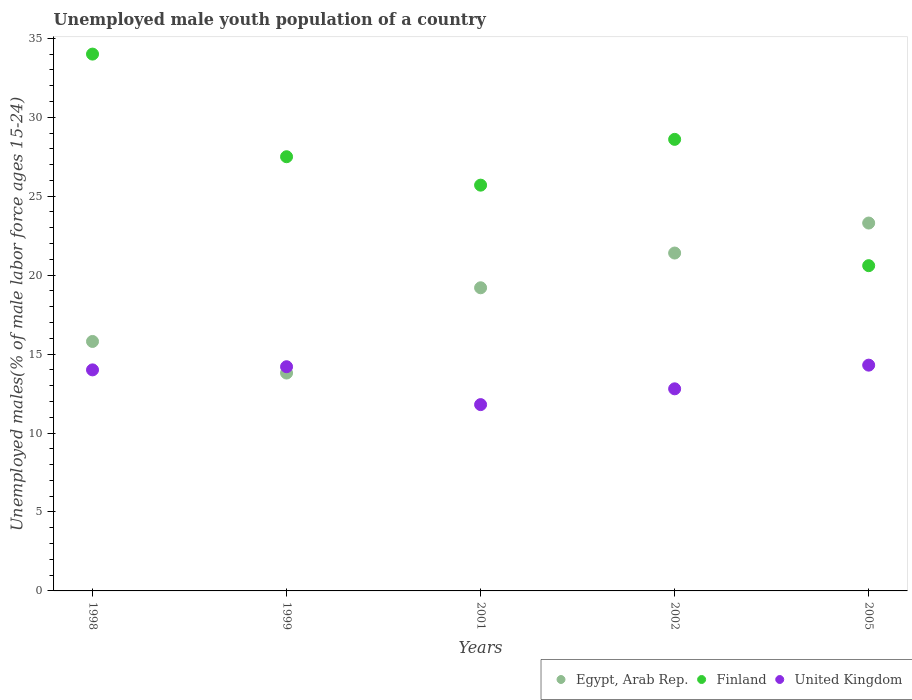How many different coloured dotlines are there?
Offer a terse response. 3. What is the percentage of unemployed male youth population in Egypt, Arab Rep. in 2001?
Keep it short and to the point. 19.2. Across all years, what is the maximum percentage of unemployed male youth population in Egypt, Arab Rep.?
Offer a terse response. 23.3. Across all years, what is the minimum percentage of unemployed male youth population in United Kingdom?
Offer a terse response. 11.8. In which year was the percentage of unemployed male youth population in Egypt, Arab Rep. maximum?
Provide a short and direct response. 2005. What is the total percentage of unemployed male youth population in Finland in the graph?
Give a very brief answer. 136.4. What is the difference between the percentage of unemployed male youth population in United Kingdom in 1998 and that in 2001?
Your answer should be compact. 2.2. What is the difference between the percentage of unemployed male youth population in Egypt, Arab Rep. in 2005 and the percentage of unemployed male youth population in Finland in 2001?
Provide a succinct answer. -2.4. What is the average percentage of unemployed male youth population in Egypt, Arab Rep. per year?
Your response must be concise. 18.7. In the year 2001, what is the difference between the percentage of unemployed male youth population in Finland and percentage of unemployed male youth population in United Kingdom?
Your answer should be compact. 13.9. What is the ratio of the percentage of unemployed male youth population in Finland in 1999 to that in 2001?
Keep it short and to the point. 1.07. Is the percentage of unemployed male youth population in United Kingdom in 1998 less than that in 1999?
Offer a terse response. Yes. What is the difference between the highest and the second highest percentage of unemployed male youth population in Egypt, Arab Rep.?
Provide a succinct answer. 1.9. What is the difference between the highest and the lowest percentage of unemployed male youth population in United Kingdom?
Offer a very short reply. 2.5. Is the sum of the percentage of unemployed male youth population in Egypt, Arab Rep. in 1999 and 2001 greater than the maximum percentage of unemployed male youth population in United Kingdom across all years?
Give a very brief answer. Yes. Does the percentage of unemployed male youth population in Finland monotonically increase over the years?
Provide a succinct answer. No. Is the percentage of unemployed male youth population in Egypt, Arab Rep. strictly less than the percentage of unemployed male youth population in United Kingdom over the years?
Your answer should be very brief. No. How many dotlines are there?
Make the answer very short. 3. What is the difference between two consecutive major ticks on the Y-axis?
Your response must be concise. 5. Where does the legend appear in the graph?
Your answer should be compact. Bottom right. How are the legend labels stacked?
Provide a short and direct response. Horizontal. What is the title of the graph?
Offer a very short reply. Unemployed male youth population of a country. Does "Singapore" appear as one of the legend labels in the graph?
Make the answer very short. No. What is the label or title of the X-axis?
Give a very brief answer. Years. What is the label or title of the Y-axis?
Ensure brevity in your answer.  Unemployed males(% of male labor force ages 15-24). What is the Unemployed males(% of male labor force ages 15-24) of Egypt, Arab Rep. in 1998?
Your response must be concise. 15.8. What is the Unemployed males(% of male labor force ages 15-24) of United Kingdom in 1998?
Ensure brevity in your answer.  14. What is the Unemployed males(% of male labor force ages 15-24) of Egypt, Arab Rep. in 1999?
Keep it short and to the point. 13.8. What is the Unemployed males(% of male labor force ages 15-24) of Finland in 1999?
Your answer should be very brief. 27.5. What is the Unemployed males(% of male labor force ages 15-24) in United Kingdom in 1999?
Ensure brevity in your answer.  14.2. What is the Unemployed males(% of male labor force ages 15-24) in Egypt, Arab Rep. in 2001?
Offer a terse response. 19.2. What is the Unemployed males(% of male labor force ages 15-24) in Finland in 2001?
Your answer should be compact. 25.7. What is the Unemployed males(% of male labor force ages 15-24) of United Kingdom in 2001?
Your answer should be compact. 11.8. What is the Unemployed males(% of male labor force ages 15-24) in Egypt, Arab Rep. in 2002?
Ensure brevity in your answer.  21.4. What is the Unemployed males(% of male labor force ages 15-24) in Finland in 2002?
Provide a succinct answer. 28.6. What is the Unemployed males(% of male labor force ages 15-24) in United Kingdom in 2002?
Ensure brevity in your answer.  12.8. What is the Unemployed males(% of male labor force ages 15-24) in Egypt, Arab Rep. in 2005?
Keep it short and to the point. 23.3. What is the Unemployed males(% of male labor force ages 15-24) in Finland in 2005?
Your answer should be very brief. 20.6. What is the Unemployed males(% of male labor force ages 15-24) in United Kingdom in 2005?
Keep it short and to the point. 14.3. Across all years, what is the maximum Unemployed males(% of male labor force ages 15-24) in Egypt, Arab Rep.?
Give a very brief answer. 23.3. Across all years, what is the maximum Unemployed males(% of male labor force ages 15-24) in United Kingdom?
Your answer should be very brief. 14.3. Across all years, what is the minimum Unemployed males(% of male labor force ages 15-24) of Egypt, Arab Rep.?
Provide a short and direct response. 13.8. Across all years, what is the minimum Unemployed males(% of male labor force ages 15-24) in Finland?
Keep it short and to the point. 20.6. Across all years, what is the minimum Unemployed males(% of male labor force ages 15-24) in United Kingdom?
Your answer should be very brief. 11.8. What is the total Unemployed males(% of male labor force ages 15-24) in Egypt, Arab Rep. in the graph?
Ensure brevity in your answer.  93.5. What is the total Unemployed males(% of male labor force ages 15-24) of Finland in the graph?
Keep it short and to the point. 136.4. What is the total Unemployed males(% of male labor force ages 15-24) in United Kingdom in the graph?
Provide a short and direct response. 67.1. What is the difference between the Unemployed males(% of male labor force ages 15-24) in Egypt, Arab Rep. in 1998 and that in 1999?
Offer a very short reply. 2. What is the difference between the Unemployed males(% of male labor force ages 15-24) of Finland in 1998 and that in 2001?
Offer a terse response. 8.3. What is the difference between the Unemployed males(% of male labor force ages 15-24) of Egypt, Arab Rep. in 1998 and that in 2002?
Keep it short and to the point. -5.6. What is the difference between the Unemployed males(% of male labor force ages 15-24) of Finland in 1998 and that in 2002?
Provide a succinct answer. 5.4. What is the difference between the Unemployed males(% of male labor force ages 15-24) of Egypt, Arab Rep. in 1998 and that in 2005?
Your answer should be very brief. -7.5. What is the difference between the Unemployed males(% of male labor force ages 15-24) of Finland in 1998 and that in 2005?
Your answer should be compact. 13.4. What is the difference between the Unemployed males(% of male labor force ages 15-24) of United Kingdom in 1999 and that in 2002?
Ensure brevity in your answer.  1.4. What is the difference between the Unemployed males(% of male labor force ages 15-24) of Egypt, Arab Rep. in 1999 and that in 2005?
Offer a terse response. -9.5. What is the difference between the Unemployed males(% of male labor force ages 15-24) in United Kingdom in 2001 and that in 2002?
Offer a terse response. -1. What is the difference between the Unemployed males(% of male labor force ages 15-24) of Egypt, Arab Rep. in 2001 and that in 2005?
Your answer should be compact. -4.1. What is the difference between the Unemployed males(% of male labor force ages 15-24) of Finland in 2001 and that in 2005?
Provide a short and direct response. 5.1. What is the difference between the Unemployed males(% of male labor force ages 15-24) in Egypt, Arab Rep. in 2002 and that in 2005?
Provide a succinct answer. -1.9. What is the difference between the Unemployed males(% of male labor force ages 15-24) in Egypt, Arab Rep. in 1998 and the Unemployed males(% of male labor force ages 15-24) in Finland in 1999?
Give a very brief answer. -11.7. What is the difference between the Unemployed males(% of male labor force ages 15-24) of Finland in 1998 and the Unemployed males(% of male labor force ages 15-24) of United Kingdom in 1999?
Give a very brief answer. 19.8. What is the difference between the Unemployed males(% of male labor force ages 15-24) of Egypt, Arab Rep. in 1998 and the Unemployed males(% of male labor force ages 15-24) of United Kingdom in 2001?
Your response must be concise. 4. What is the difference between the Unemployed males(% of male labor force ages 15-24) in Finland in 1998 and the Unemployed males(% of male labor force ages 15-24) in United Kingdom in 2002?
Make the answer very short. 21.2. What is the difference between the Unemployed males(% of male labor force ages 15-24) in Egypt, Arab Rep. in 1998 and the Unemployed males(% of male labor force ages 15-24) in Finland in 2005?
Your answer should be very brief. -4.8. What is the difference between the Unemployed males(% of male labor force ages 15-24) of Finland in 1998 and the Unemployed males(% of male labor force ages 15-24) of United Kingdom in 2005?
Your response must be concise. 19.7. What is the difference between the Unemployed males(% of male labor force ages 15-24) in Egypt, Arab Rep. in 1999 and the Unemployed males(% of male labor force ages 15-24) in Finland in 2001?
Ensure brevity in your answer.  -11.9. What is the difference between the Unemployed males(% of male labor force ages 15-24) of Finland in 1999 and the Unemployed males(% of male labor force ages 15-24) of United Kingdom in 2001?
Give a very brief answer. 15.7. What is the difference between the Unemployed males(% of male labor force ages 15-24) of Egypt, Arab Rep. in 1999 and the Unemployed males(% of male labor force ages 15-24) of Finland in 2002?
Provide a succinct answer. -14.8. What is the difference between the Unemployed males(% of male labor force ages 15-24) in Egypt, Arab Rep. in 1999 and the Unemployed males(% of male labor force ages 15-24) in United Kingdom in 2002?
Give a very brief answer. 1. What is the difference between the Unemployed males(% of male labor force ages 15-24) in Finland in 1999 and the Unemployed males(% of male labor force ages 15-24) in United Kingdom in 2002?
Make the answer very short. 14.7. What is the difference between the Unemployed males(% of male labor force ages 15-24) of Egypt, Arab Rep. in 1999 and the Unemployed males(% of male labor force ages 15-24) of Finland in 2005?
Make the answer very short. -6.8. What is the difference between the Unemployed males(% of male labor force ages 15-24) of Finland in 1999 and the Unemployed males(% of male labor force ages 15-24) of United Kingdom in 2005?
Ensure brevity in your answer.  13.2. What is the difference between the Unemployed males(% of male labor force ages 15-24) in Egypt, Arab Rep. in 2001 and the Unemployed males(% of male labor force ages 15-24) in Finland in 2002?
Your answer should be compact. -9.4. What is the difference between the Unemployed males(% of male labor force ages 15-24) in Egypt, Arab Rep. in 2001 and the Unemployed males(% of male labor force ages 15-24) in United Kingdom in 2005?
Your response must be concise. 4.9. What is the difference between the Unemployed males(% of male labor force ages 15-24) of Finland in 2001 and the Unemployed males(% of male labor force ages 15-24) of United Kingdom in 2005?
Your answer should be very brief. 11.4. What is the difference between the Unemployed males(% of male labor force ages 15-24) in Egypt, Arab Rep. in 2002 and the Unemployed males(% of male labor force ages 15-24) in Finland in 2005?
Your answer should be compact. 0.8. What is the average Unemployed males(% of male labor force ages 15-24) of Finland per year?
Give a very brief answer. 27.28. What is the average Unemployed males(% of male labor force ages 15-24) in United Kingdom per year?
Your response must be concise. 13.42. In the year 1998, what is the difference between the Unemployed males(% of male labor force ages 15-24) of Egypt, Arab Rep. and Unemployed males(% of male labor force ages 15-24) of Finland?
Offer a terse response. -18.2. In the year 1998, what is the difference between the Unemployed males(% of male labor force ages 15-24) in Finland and Unemployed males(% of male labor force ages 15-24) in United Kingdom?
Offer a terse response. 20. In the year 1999, what is the difference between the Unemployed males(% of male labor force ages 15-24) of Egypt, Arab Rep. and Unemployed males(% of male labor force ages 15-24) of Finland?
Make the answer very short. -13.7. In the year 1999, what is the difference between the Unemployed males(% of male labor force ages 15-24) in Egypt, Arab Rep. and Unemployed males(% of male labor force ages 15-24) in United Kingdom?
Your answer should be very brief. -0.4. In the year 2001, what is the difference between the Unemployed males(% of male labor force ages 15-24) of Egypt, Arab Rep. and Unemployed males(% of male labor force ages 15-24) of Finland?
Give a very brief answer. -6.5. In the year 2001, what is the difference between the Unemployed males(% of male labor force ages 15-24) of Finland and Unemployed males(% of male labor force ages 15-24) of United Kingdom?
Make the answer very short. 13.9. In the year 2002, what is the difference between the Unemployed males(% of male labor force ages 15-24) in Egypt, Arab Rep. and Unemployed males(% of male labor force ages 15-24) in United Kingdom?
Your answer should be very brief. 8.6. In the year 2002, what is the difference between the Unemployed males(% of male labor force ages 15-24) in Finland and Unemployed males(% of male labor force ages 15-24) in United Kingdom?
Make the answer very short. 15.8. In the year 2005, what is the difference between the Unemployed males(% of male labor force ages 15-24) in Egypt, Arab Rep. and Unemployed males(% of male labor force ages 15-24) in United Kingdom?
Make the answer very short. 9. In the year 2005, what is the difference between the Unemployed males(% of male labor force ages 15-24) in Finland and Unemployed males(% of male labor force ages 15-24) in United Kingdom?
Offer a terse response. 6.3. What is the ratio of the Unemployed males(% of male labor force ages 15-24) of Egypt, Arab Rep. in 1998 to that in 1999?
Your answer should be compact. 1.14. What is the ratio of the Unemployed males(% of male labor force ages 15-24) in Finland in 1998 to that in 1999?
Your answer should be compact. 1.24. What is the ratio of the Unemployed males(% of male labor force ages 15-24) in United Kingdom in 1998 to that in 1999?
Your answer should be compact. 0.99. What is the ratio of the Unemployed males(% of male labor force ages 15-24) in Egypt, Arab Rep. in 1998 to that in 2001?
Your answer should be compact. 0.82. What is the ratio of the Unemployed males(% of male labor force ages 15-24) in Finland in 1998 to that in 2001?
Give a very brief answer. 1.32. What is the ratio of the Unemployed males(% of male labor force ages 15-24) in United Kingdom in 1998 to that in 2001?
Your answer should be very brief. 1.19. What is the ratio of the Unemployed males(% of male labor force ages 15-24) in Egypt, Arab Rep. in 1998 to that in 2002?
Provide a succinct answer. 0.74. What is the ratio of the Unemployed males(% of male labor force ages 15-24) of Finland in 1998 to that in 2002?
Your answer should be very brief. 1.19. What is the ratio of the Unemployed males(% of male labor force ages 15-24) in United Kingdom in 1998 to that in 2002?
Make the answer very short. 1.09. What is the ratio of the Unemployed males(% of male labor force ages 15-24) in Egypt, Arab Rep. in 1998 to that in 2005?
Provide a succinct answer. 0.68. What is the ratio of the Unemployed males(% of male labor force ages 15-24) in Finland in 1998 to that in 2005?
Offer a terse response. 1.65. What is the ratio of the Unemployed males(% of male labor force ages 15-24) of Egypt, Arab Rep. in 1999 to that in 2001?
Your answer should be very brief. 0.72. What is the ratio of the Unemployed males(% of male labor force ages 15-24) of Finland in 1999 to that in 2001?
Your response must be concise. 1.07. What is the ratio of the Unemployed males(% of male labor force ages 15-24) of United Kingdom in 1999 to that in 2001?
Ensure brevity in your answer.  1.2. What is the ratio of the Unemployed males(% of male labor force ages 15-24) in Egypt, Arab Rep. in 1999 to that in 2002?
Your response must be concise. 0.64. What is the ratio of the Unemployed males(% of male labor force ages 15-24) of Finland in 1999 to that in 2002?
Provide a short and direct response. 0.96. What is the ratio of the Unemployed males(% of male labor force ages 15-24) of United Kingdom in 1999 to that in 2002?
Keep it short and to the point. 1.11. What is the ratio of the Unemployed males(% of male labor force ages 15-24) in Egypt, Arab Rep. in 1999 to that in 2005?
Ensure brevity in your answer.  0.59. What is the ratio of the Unemployed males(% of male labor force ages 15-24) in Finland in 1999 to that in 2005?
Offer a terse response. 1.33. What is the ratio of the Unemployed males(% of male labor force ages 15-24) in United Kingdom in 1999 to that in 2005?
Your answer should be very brief. 0.99. What is the ratio of the Unemployed males(% of male labor force ages 15-24) of Egypt, Arab Rep. in 2001 to that in 2002?
Your answer should be compact. 0.9. What is the ratio of the Unemployed males(% of male labor force ages 15-24) of Finland in 2001 to that in 2002?
Your answer should be compact. 0.9. What is the ratio of the Unemployed males(% of male labor force ages 15-24) in United Kingdom in 2001 to that in 2002?
Your answer should be compact. 0.92. What is the ratio of the Unemployed males(% of male labor force ages 15-24) in Egypt, Arab Rep. in 2001 to that in 2005?
Keep it short and to the point. 0.82. What is the ratio of the Unemployed males(% of male labor force ages 15-24) in Finland in 2001 to that in 2005?
Offer a terse response. 1.25. What is the ratio of the Unemployed males(% of male labor force ages 15-24) of United Kingdom in 2001 to that in 2005?
Your answer should be compact. 0.83. What is the ratio of the Unemployed males(% of male labor force ages 15-24) in Egypt, Arab Rep. in 2002 to that in 2005?
Make the answer very short. 0.92. What is the ratio of the Unemployed males(% of male labor force ages 15-24) of Finland in 2002 to that in 2005?
Ensure brevity in your answer.  1.39. What is the ratio of the Unemployed males(% of male labor force ages 15-24) of United Kingdom in 2002 to that in 2005?
Your answer should be very brief. 0.9. What is the difference between the highest and the second highest Unemployed males(% of male labor force ages 15-24) in Egypt, Arab Rep.?
Make the answer very short. 1.9. What is the difference between the highest and the second highest Unemployed males(% of male labor force ages 15-24) in United Kingdom?
Provide a short and direct response. 0.1. 